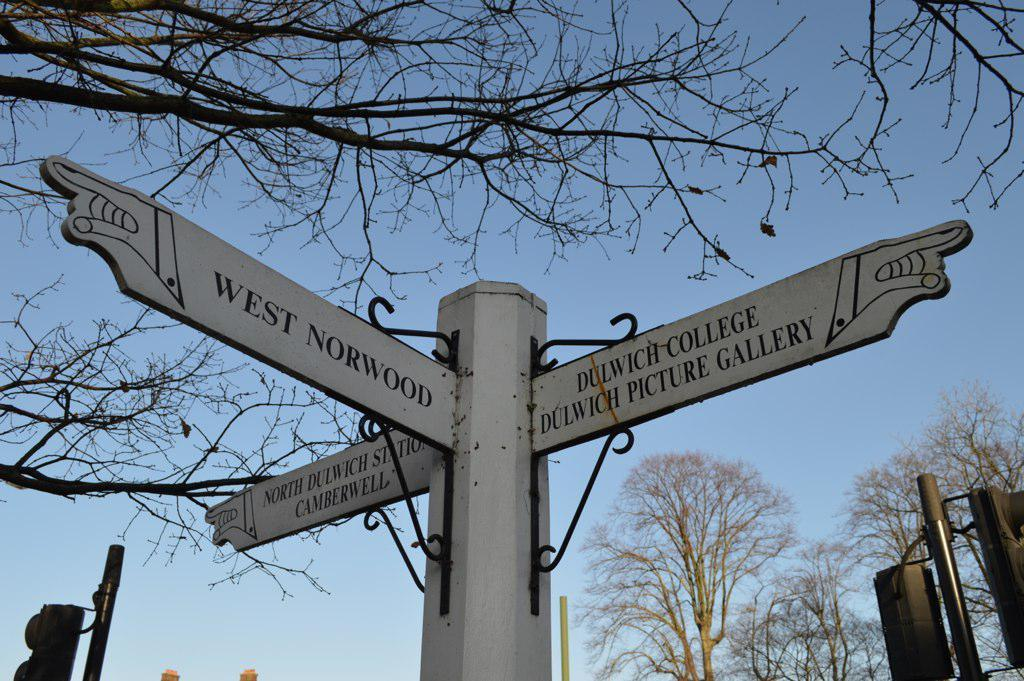What is the main object in the center of the image? There is a sign pole in the center of the image. What can be seen at the bottom side of the image? There are traffic poles at the bottom side of the image. What type of natural elements are visible in the background of the image? There are trees in the background of the image. Can you see an argument happening between the trees in the image? There is no argument present in the image; it only features a sign pole, traffic poles, and trees. How many loaves of bread can be seen on the sign pole in the image? There are no loaves of bread present on the sign pole or anywhere else in the image. 